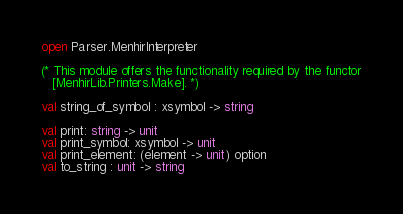Convert code to text. <code><loc_0><loc_0><loc_500><loc_500><_OCaml_>open Parser.MenhirInterpreter

(* This module offers the functionality required by the functor
   [MenhirLib.Printers.Make]. *)

val string_of_symbol : xsymbol -> string

val print: string -> unit
val print_symbol: xsymbol -> unit
val print_element: (element -> unit) option
val to_string : unit -> string
</code> 